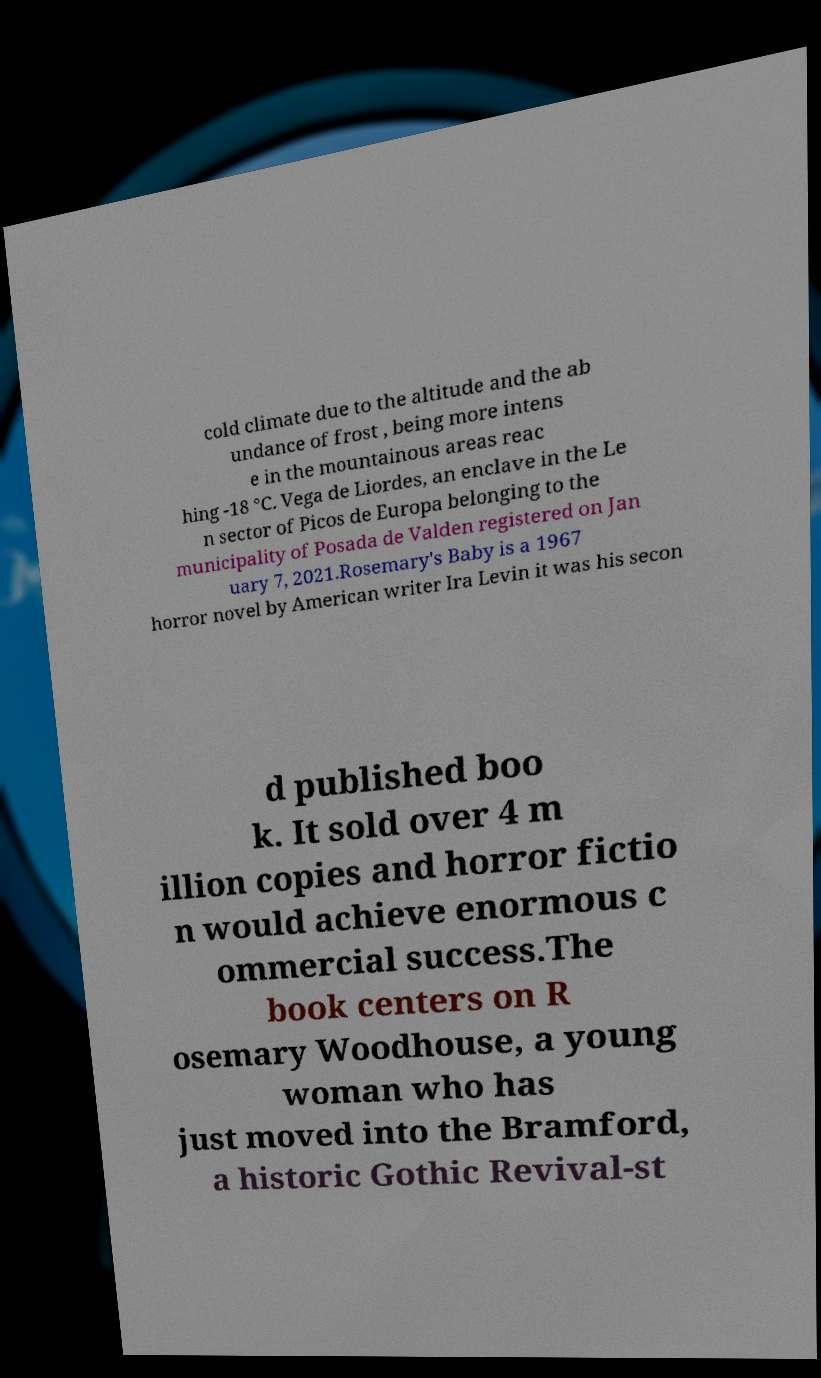There's text embedded in this image that I need extracted. Can you transcribe it verbatim? cold climate due to the altitude and the ab undance of frost , being more intens e in the mountainous areas reac hing -18 °C. Vega de Liordes, an enclave in the Le n sector of Picos de Europa belonging to the municipality of Posada de Valden registered on Jan uary 7, 2021.Rosemary's Baby is a 1967 horror novel by American writer Ira Levin it was his secon d published boo k. It sold over 4 m illion copies and horror fictio n would achieve enormous c ommercial success.The book centers on R osemary Woodhouse, a young woman who has just moved into the Bramford, a historic Gothic Revival-st 